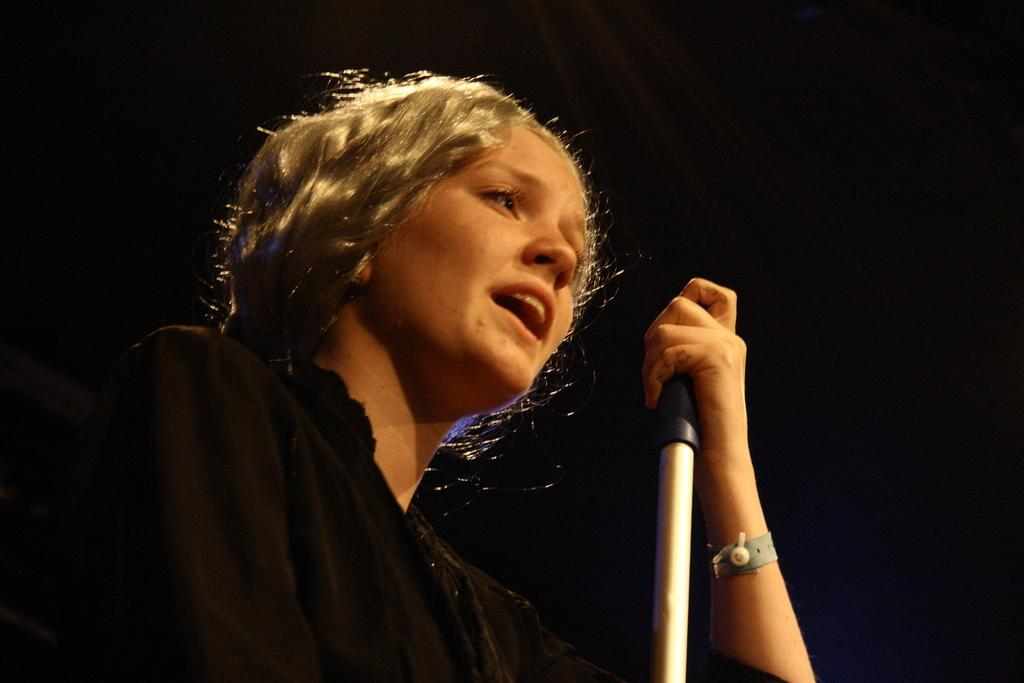Who is the main subject in the image? There is a woman in the image. What is the woman wearing? The woman is wearing a black dress. What is in front of the woman in the image? There is a stand in front of the woman. What can be observed about the background of the image? The background of the image is dark. What type of orange can be seen in the woman's hand in the image? There is no orange present in the image; the woman is not holding anything in her hand. What type of vacation is the woman planning based on the image? There is no indication of a vacation in the image; it only shows a woman standing in front of a stand with a dark background. 